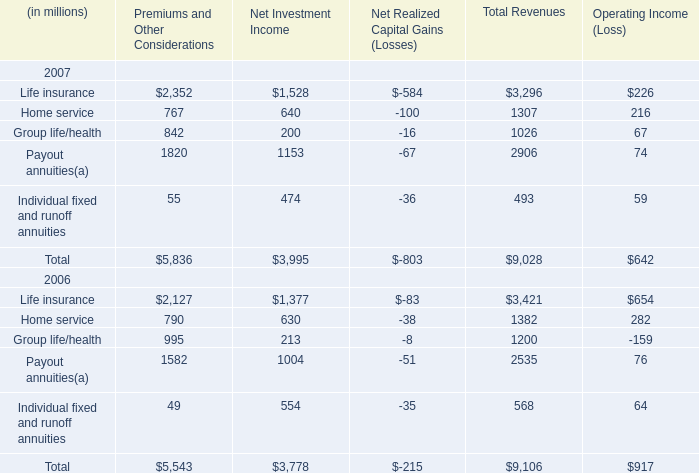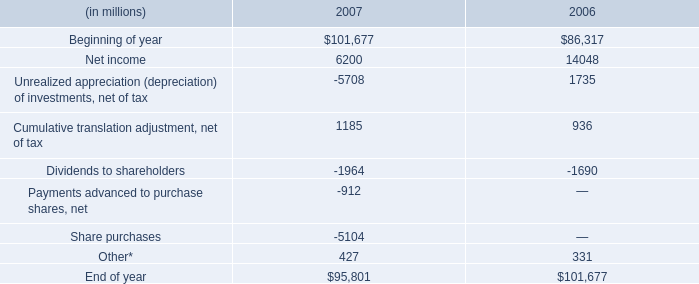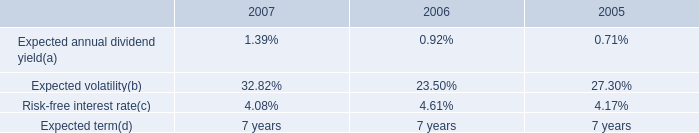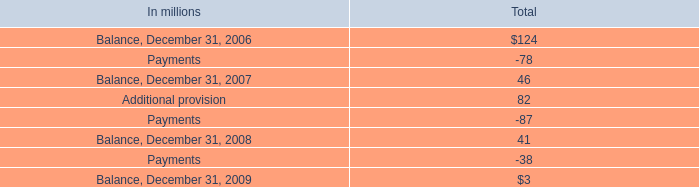What's the sum of Life insurance 2006 of Net Investment Income, Share purchases of 2007, and Dividends to shareholders of 2006 ? 
Computations: ((1377.0 + 5104.0) + 1690.0)
Answer: 8171.0. 